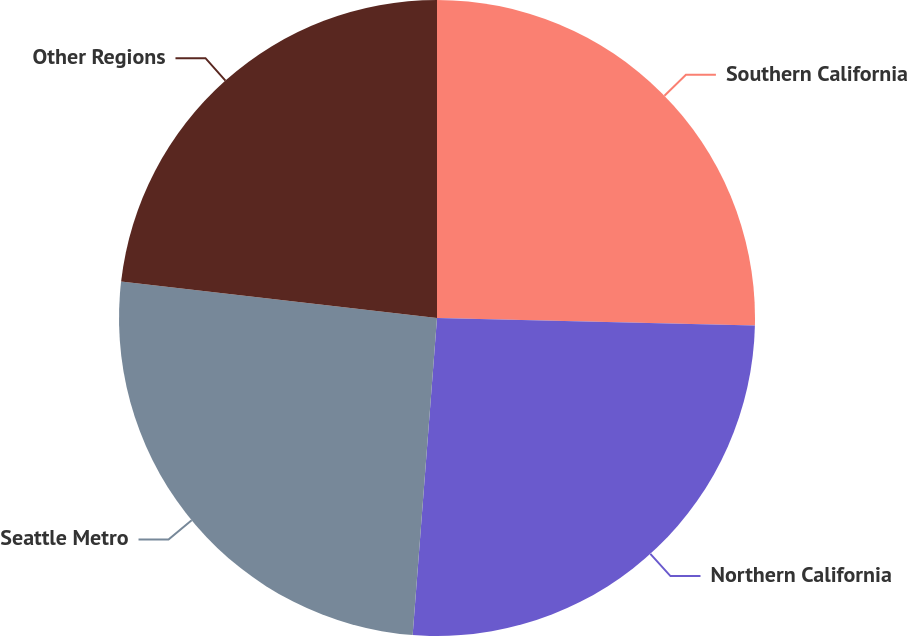Convert chart. <chart><loc_0><loc_0><loc_500><loc_500><pie_chart><fcel>Southern California<fcel>Northern California<fcel>Seattle Metro<fcel>Other Regions<nl><fcel>25.37%<fcel>25.85%<fcel>25.61%<fcel>23.17%<nl></chart> 